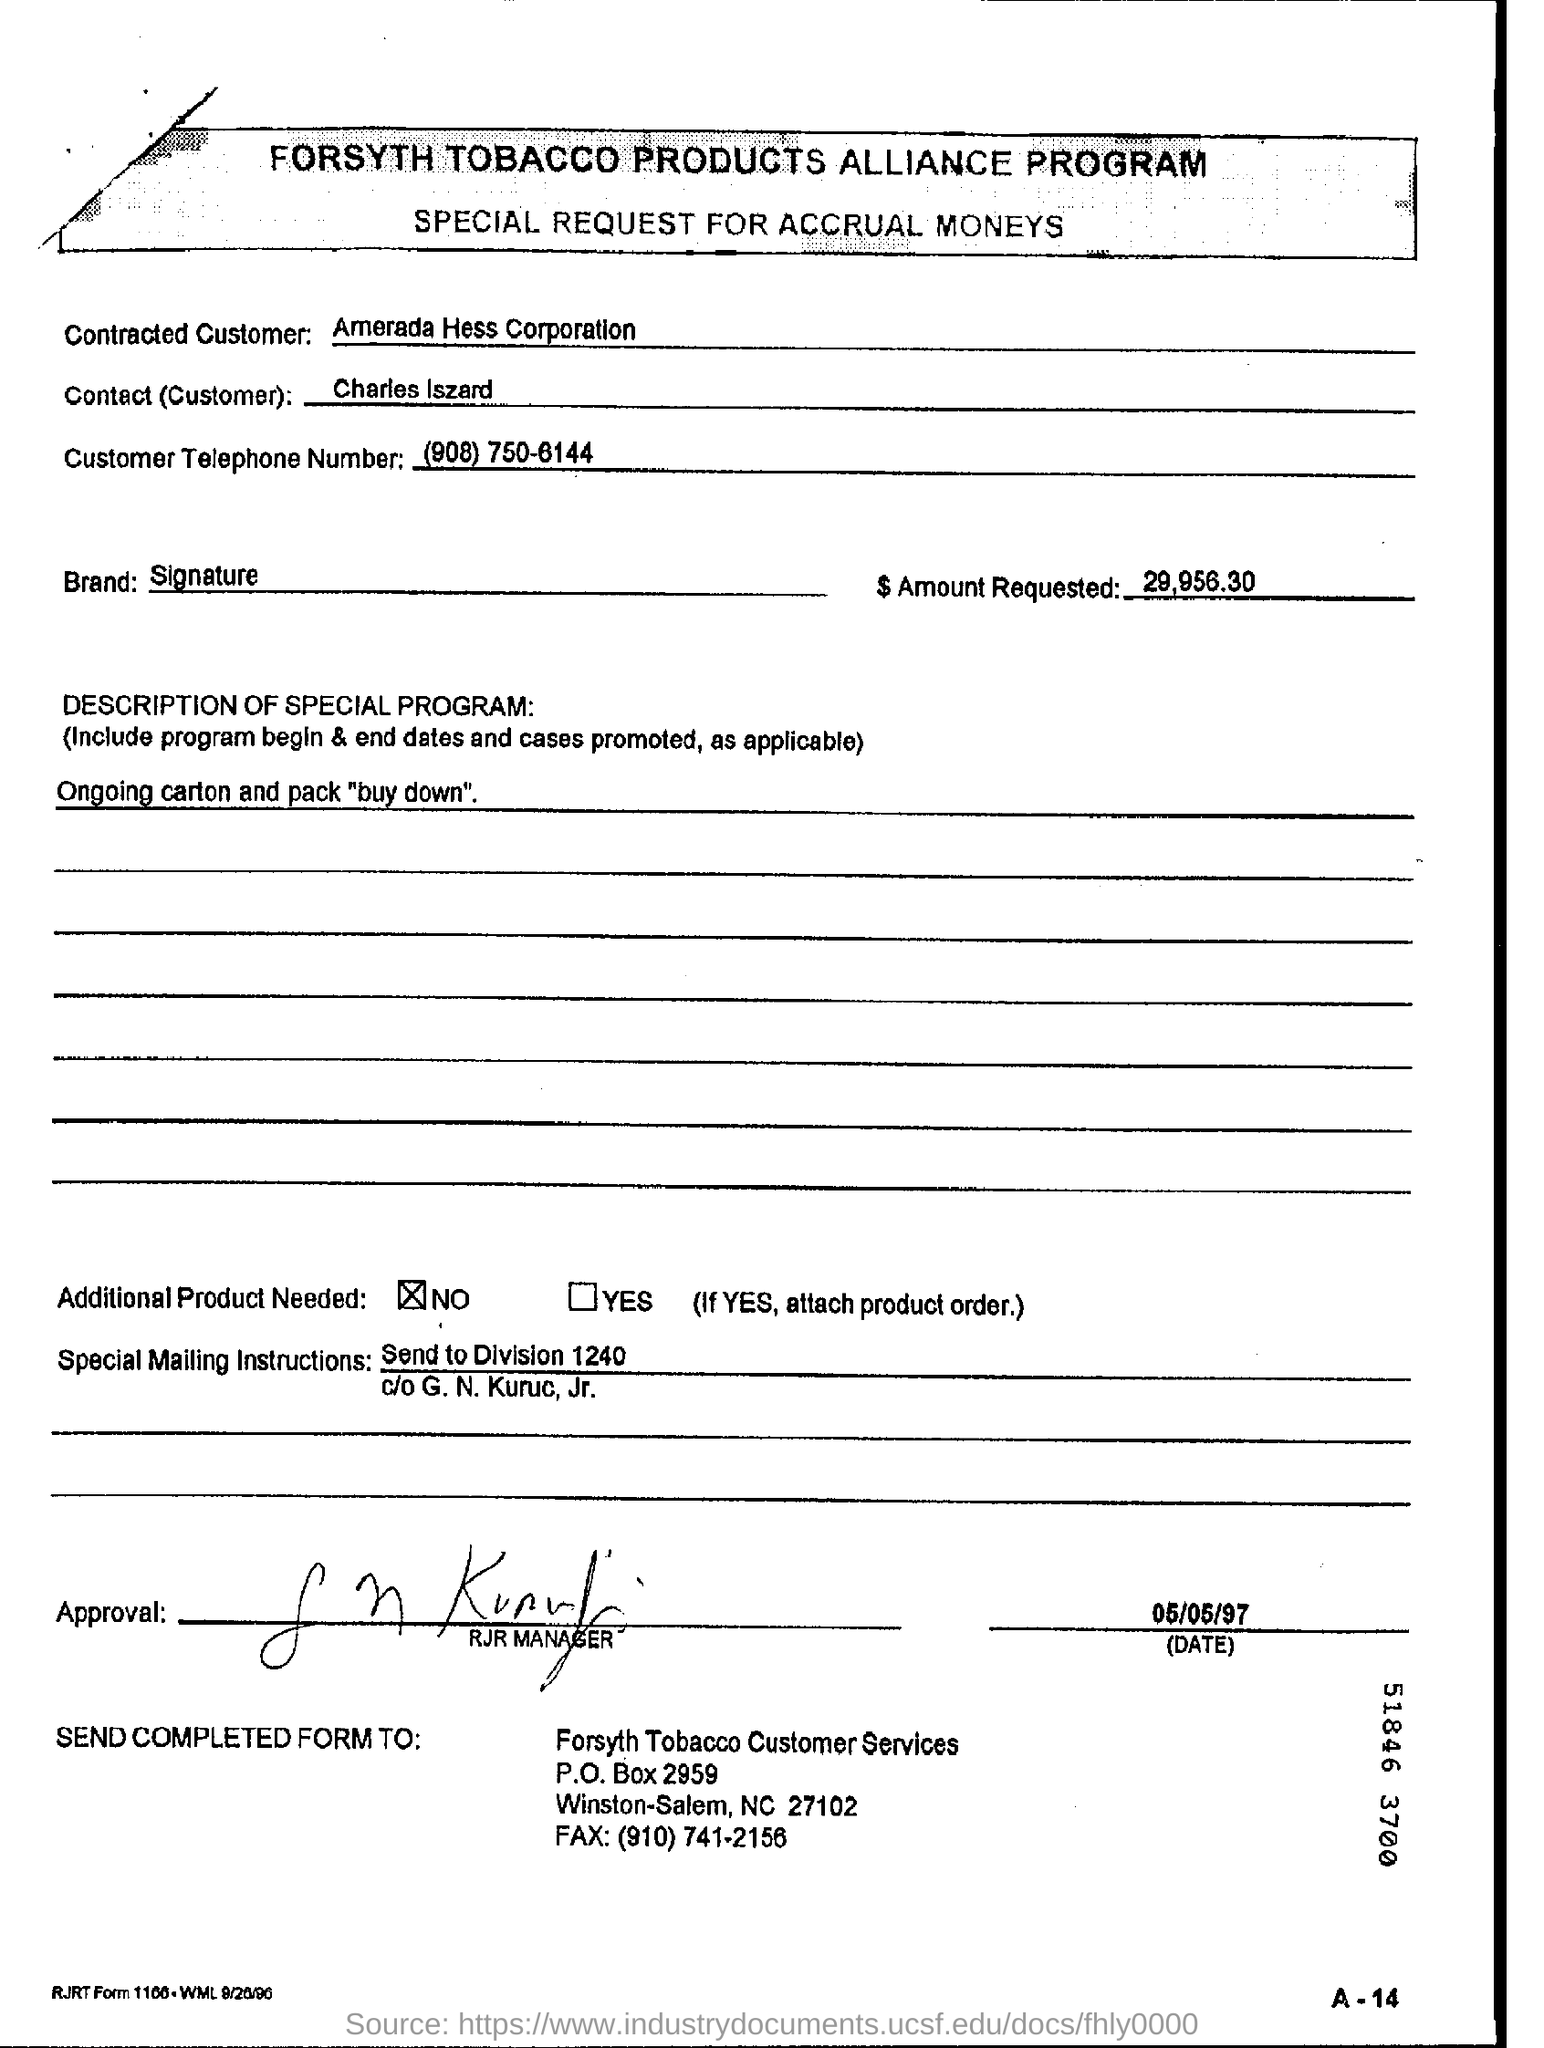Identify some key points in this picture. The customer telephone number is (908) 750-6144. The brand is Signature. The date on the document is May 5, 1997. Amerada Hess Corporation is the contracted customer. 